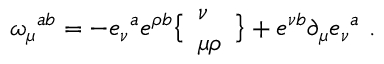<formula> <loc_0><loc_0><loc_500><loc_500>\omega _ { \mu ^ { a b } = - e _ { \nu ^ { a } e ^ { \rho b } \left \{ \begin{array} { l } { \nu } \\ { \mu \rho } \end{array} \right \} + e ^ { \nu b } \partial _ { \mu } e _ { \nu ^ { a } \ .</formula> 